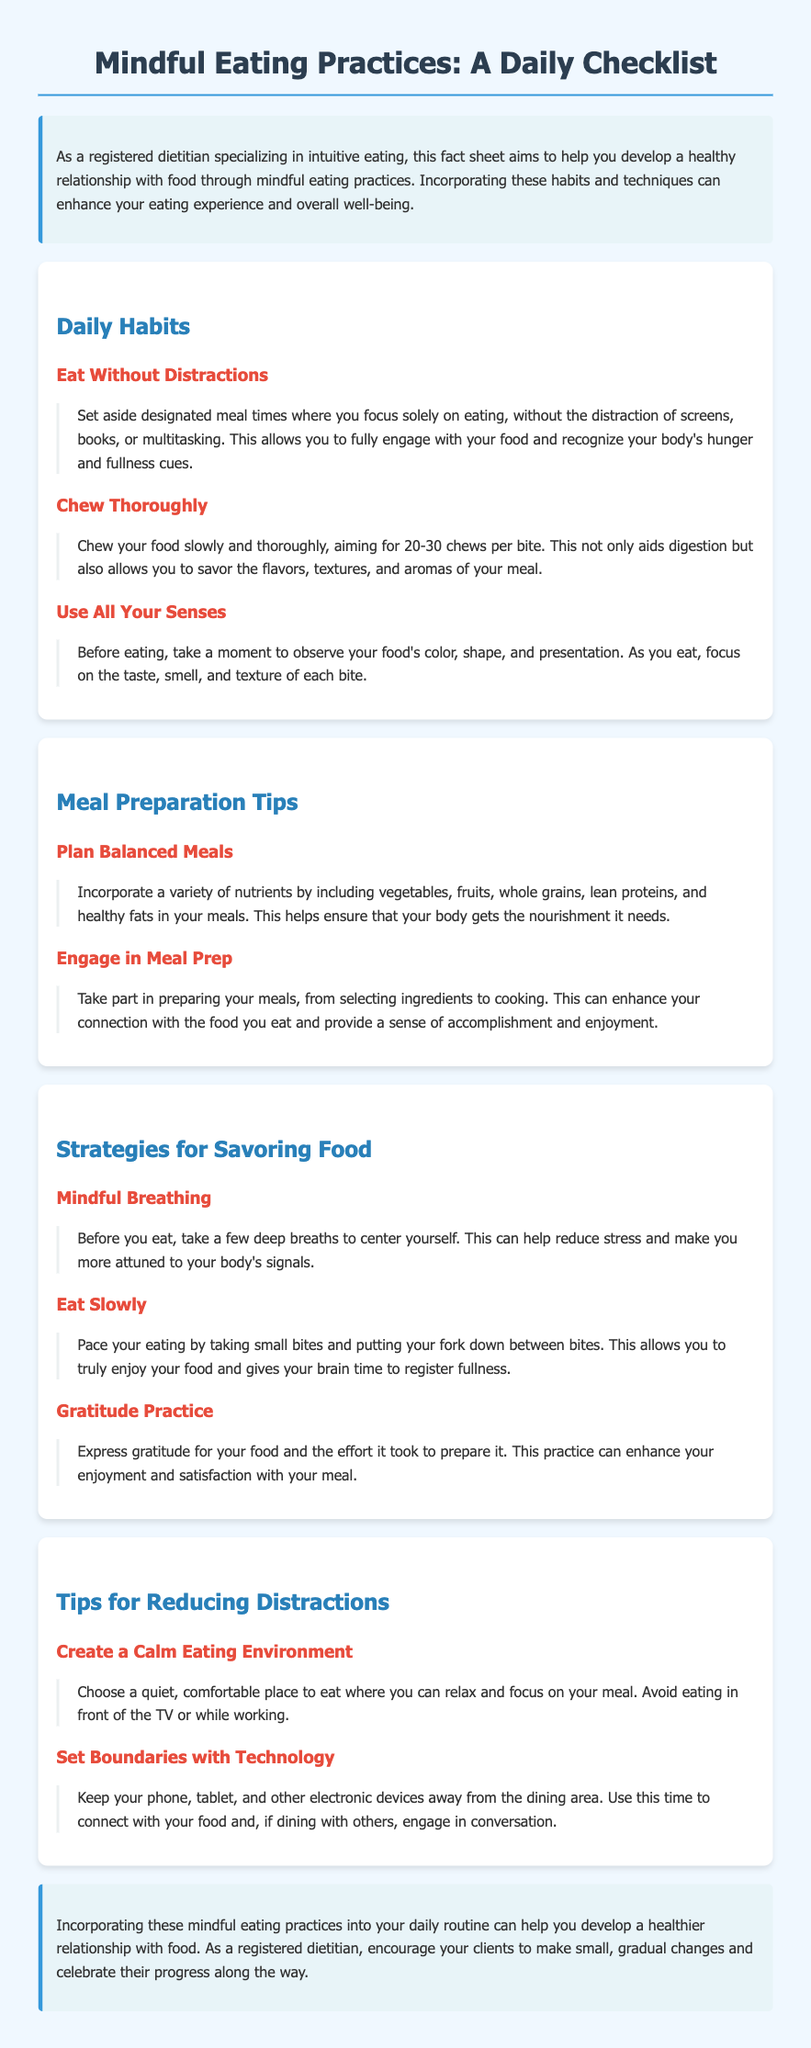what is the title of the document? The title is provided at the very top of the document, which outlines the main focus of the content.
Answer: Mindful Eating Practices: A Daily Checklist how many daily habits are listed? The section on daily habits contains a specific number of practices mentioned in the document.
Answer: 3 what is the first habit mentioned in the daily habits section? The first item in the daily habits section introduces the first practice for mindful eating.
Answer: Eat Without Distractions what is one strategy suggested for savoring food? The strategies section lists techniques to enhance the enjoyment of food, specifically naming one such approach.
Answer: Mindful Breathing how many meal preparation tips are provided? The section on meal preparation tips includes a count of the suggestions that follow under this category.
Answer: 2 what is the purpose of setting boundaries with technology during meals? The rationale for minimizing distractions is explained in the tip regarding technology.
Answer: Focus on your meal which color is used for the headings in the introduction? The introductory section has a specific color denoted for its headings, reflecting the document’s theme.
Answer: Dark blue what practice does the conclusion encourage? The conclusion emphasizes a particular mindset or behavior to promote positive food relationships.
Answer: Gradual changes what is the background color of the document? The overall background color of the document is detailed in the styling section, which sets the visual tone.
Answer: Light blue 